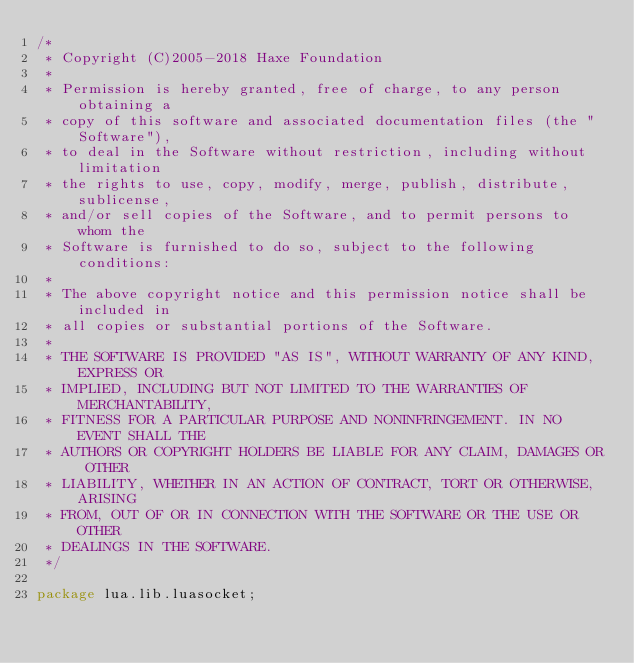Convert code to text. <code><loc_0><loc_0><loc_500><loc_500><_Haxe_>/*
 * Copyright (C)2005-2018 Haxe Foundation
 *
 * Permission is hereby granted, free of charge, to any person obtaining a
 * copy of this software and associated documentation files (the "Software"),
 * to deal in the Software without restriction, including without limitation
 * the rights to use, copy, modify, merge, publish, distribute, sublicense,
 * and/or sell copies of the Software, and to permit persons to whom the
 * Software is furnished to do so, subject to the following conditions:
 *
 * The above copyright notice and this permission notice shall be included in
 * all copies or substantial portions of the Software.
 *
 * THE SOFTWARE IS PROVIDED "AS IS", WITHOUT WARRANTY OF ANY KIND, EXPRESS OR
 * IMPLIED, INCLUDING BUT NOT LIMITED TO THE WARRANTIES OF MERCHANTABILITY,
 * FITNESS FOR A PARTICULAR PURPOSE AND NONINFRINGEMENT. IN NO EVENT SHALL THE
 * AUTHORS OR COPYRIGHT HOLDERS BE LIABLE FOR ANY CLAIM, DAMAGES OR OTHER
 * LIABILITY, WHETHER IN AN ACTION OF CONTRACT, TORT OR OTHERWISE, ARISING
 * FROM, OUT OF OR IN CONNECTION WITH THE SOFTWARE OR THE USE OR OTHER
 * DEALINGS IN THE SOFTWARE.
 */

package lua.lib.luasocket;</code> 